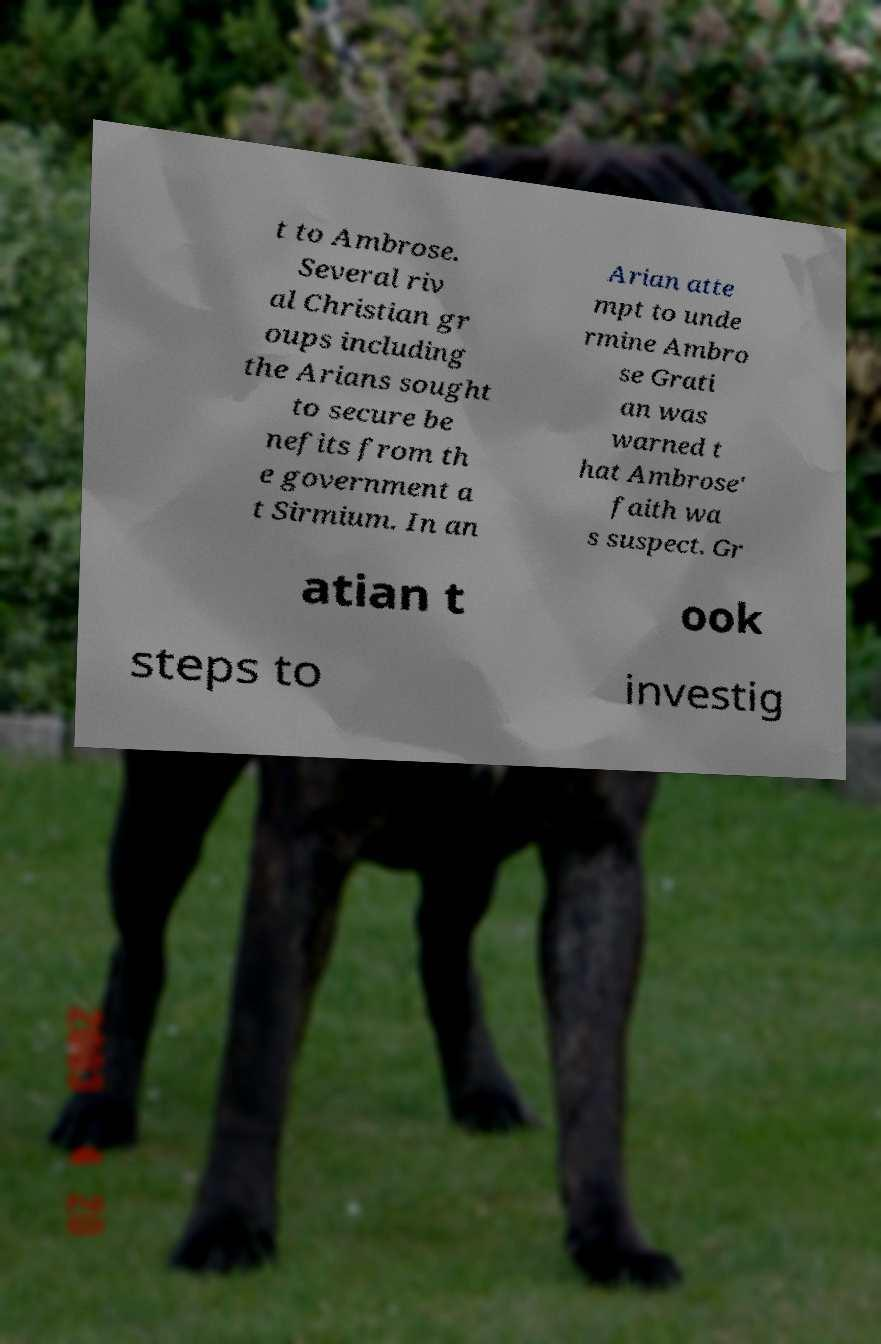Can you read and provide the text displayed in the image?This photo seems to have some interesting text. Can you extract and type it out for me? t to Ambrose. Several riv al Christian gr oups including the Arians sought to secure be nefits from th e government a t Sirmium. In an Arian atte mpt to unde rmine Ambro se Grati an was warned t hat Ambrose' faith wa s suspect. Gr atian t ook steps to investig 